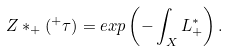<formula> <loc_0><loc_0><loc_500><loc_500>Z * _ { + } ( { ^ { + } } \tau ) = e x p \left ( - \int _ { X } L ^ { * } _ { + } \right ) .</formula> 